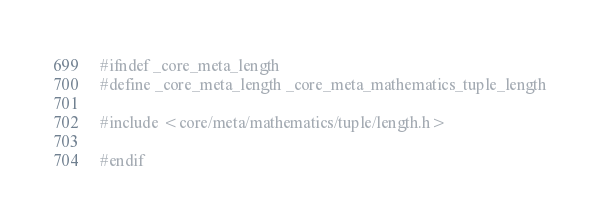Convert code to text. <code><loc_0><loc_0><loc_500><loc_500><_C_>#ifndef _core_meta_length
#define _core_meta_length _core_meta_mathematics_tuple_length

#include <core/meta/mathematics/tuple/length.h>

#endif
</code> 